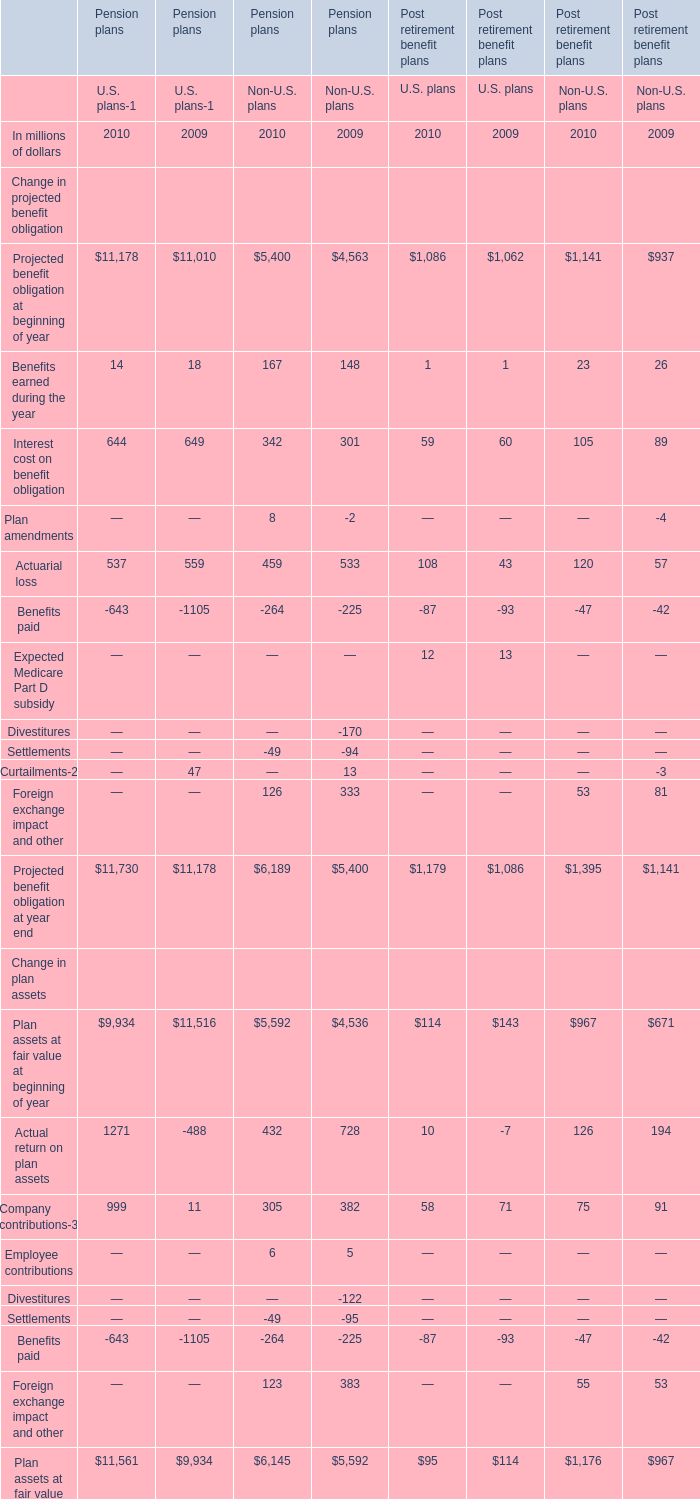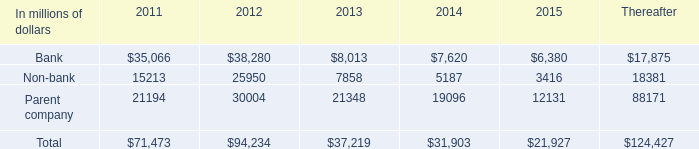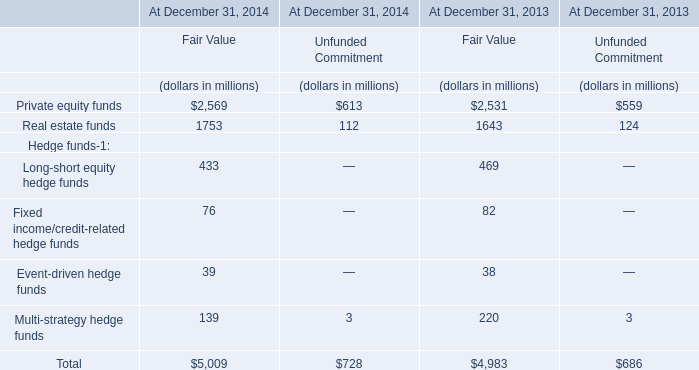what was the percentage increase in the bank subsidiary trusts 2019 obligations from 2011 to 2012 
Computations: ((38280 - 35066) - 35066)
Answer: -31852.0. 